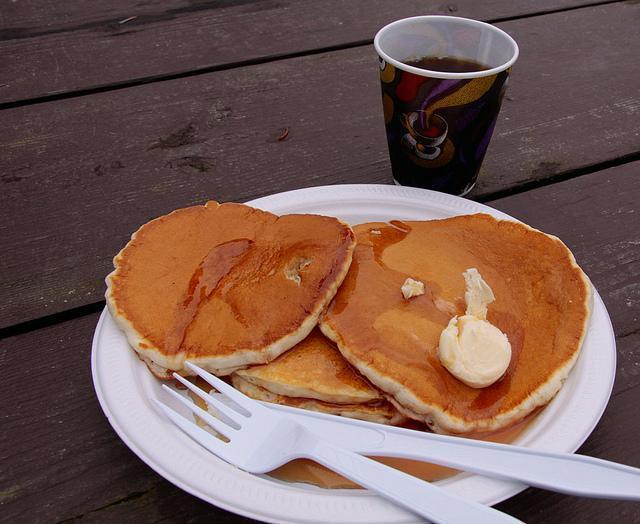How many forks can be seen?
Give a very brief answer. 1. How many cups can you see?
Give a very brief answer. 1. How many bunches of bananas are in the photo?
Give a very brief answer. 0. 